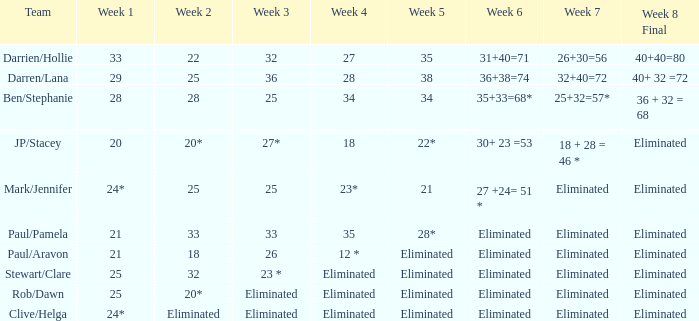Identify the team for the first week of 28. Ben/Stephanie. 